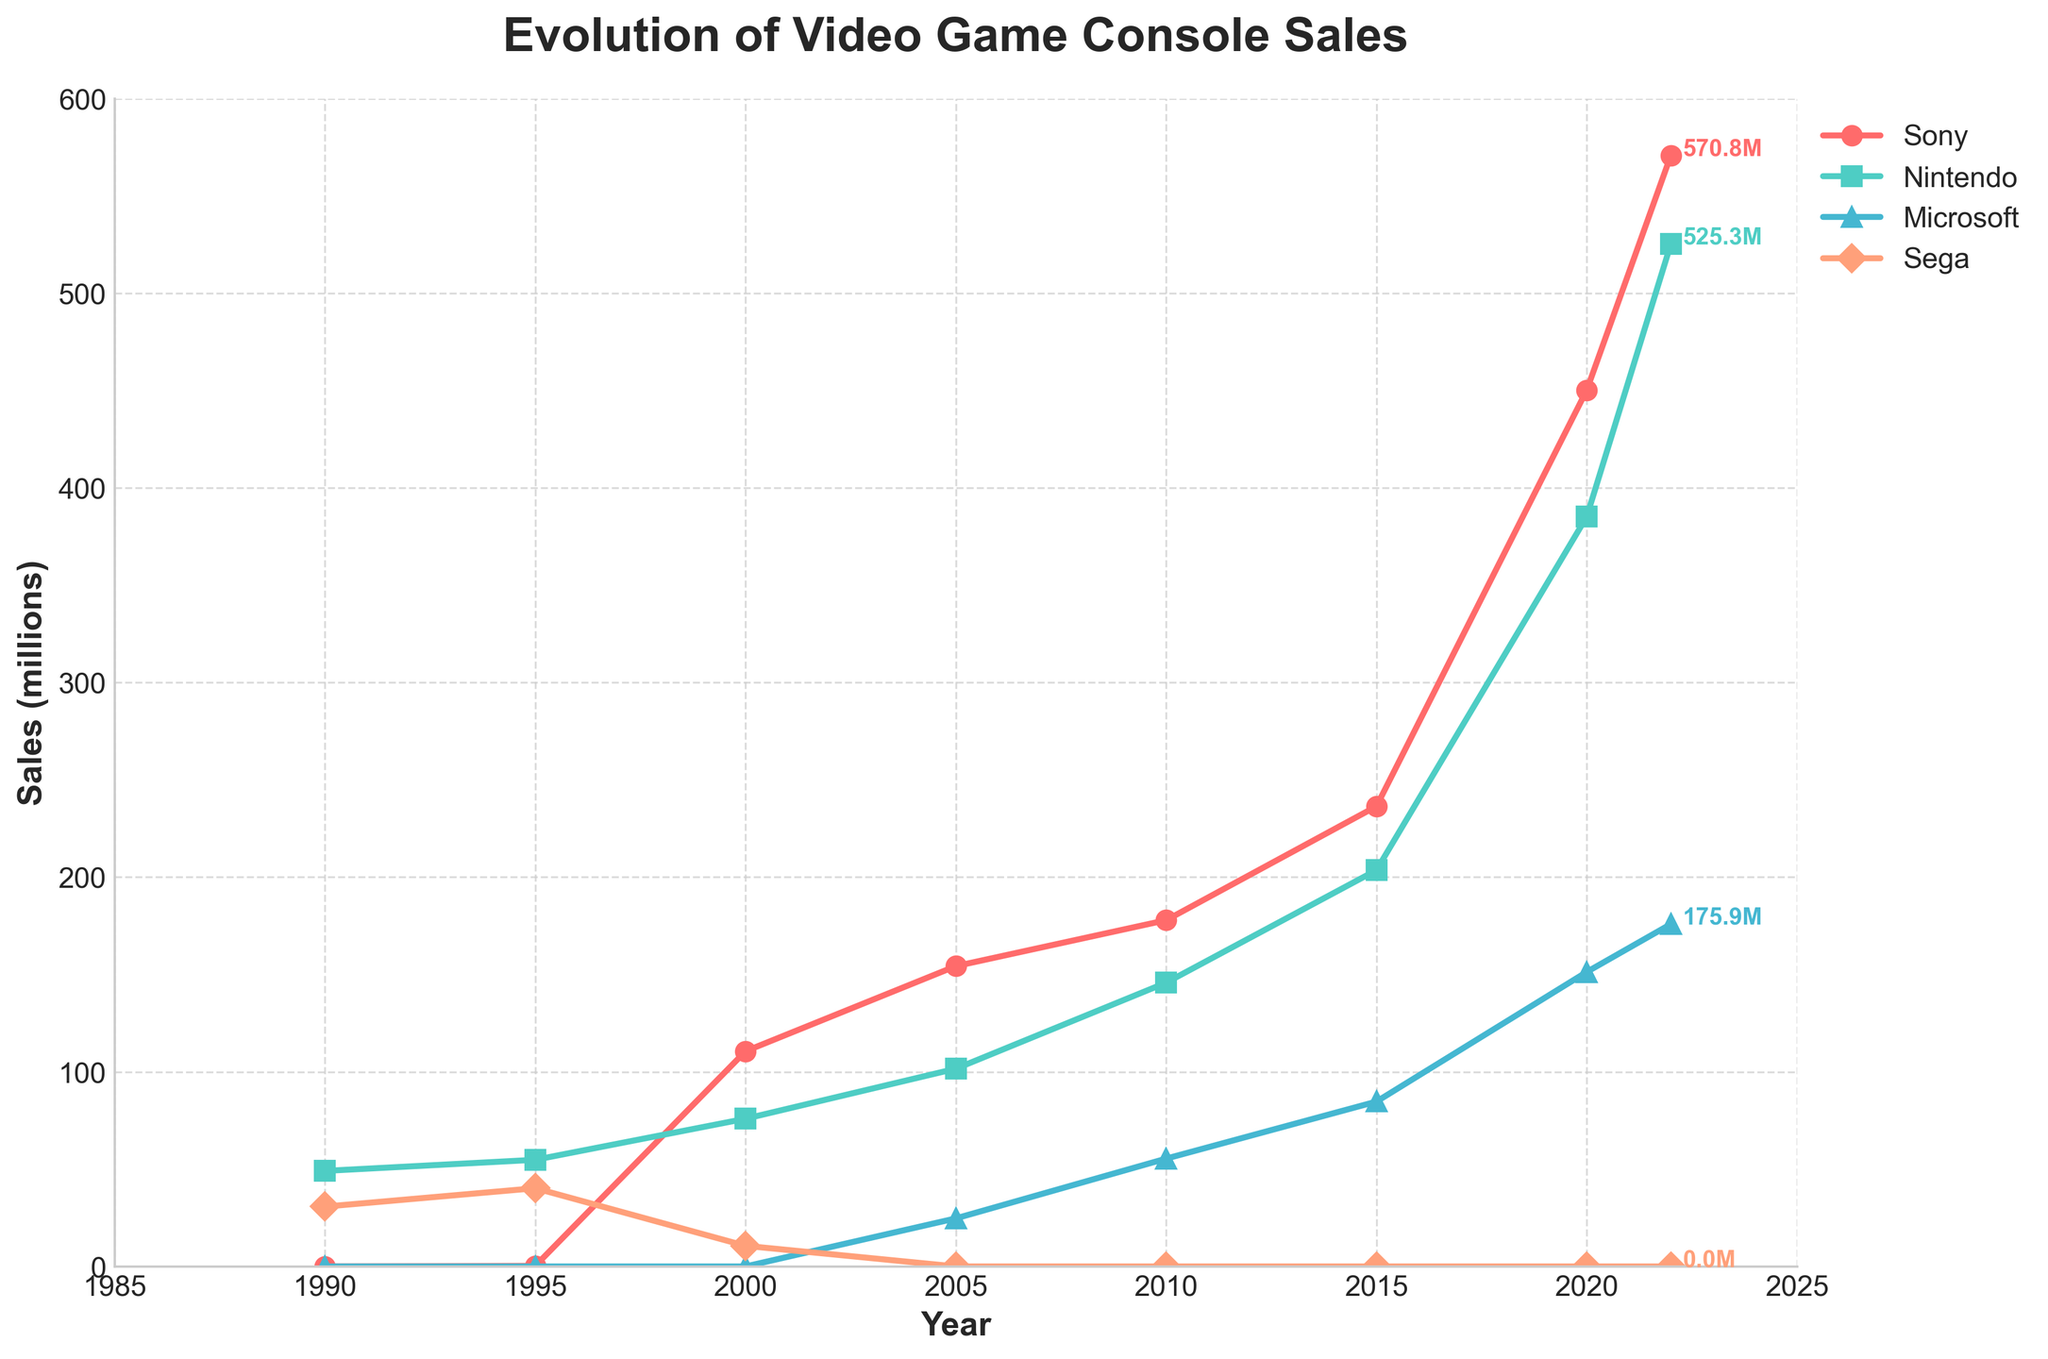Which manufacturer had the highest sales in 2022? From the figure, observe that Sony has the highest point on the curve for the year 2022 compared to Nintendo and Microsoft.
Answer: Sony By how much did Microsoft's sales increase from 2005 to 2022? Look at the sales of Microsoft for 2005 (24.7 million) and 2022 (175.9 million). Calculate the difference (175.9 - 24.7).
Answer: 151.2 million Compare the sales growth of Sony and Nintendo between 2000 and 2020. Who had a bigger increase? Calculate the difference in sales for Sony (450.2 - 110.6) and Nintendo (385.2 - 75.9). Compare the differences: Sony's increase is 339.6 million, and Nintendo's increase is 309.3 million.
Answer: Sony Which company dropped out of the market after 2000? Identify the company whose sales line ends at the year 2000. The line for Sega stops after 2000.
Answer: Sega What were the total sales for Sony, Nintendo, and Microsoft combined in 2022? Sum the sales of Sony (570.8), Nintendo (525.3), and Microsoft (175.9) for 2022 (570.8 + 525.3 + 175.9).
Answer: 1272 million Which year did Sony's sales first surpass 150 million? Identify the year when Sony's sales line crosses the 150 million mark for the first time, which happens in 2005.
Answer: 2005 What is the approximate difference in sales between Sony and Nintendo in 2020? Find the difference between Sony's sales (450.2) and Nintendo's sales (385.2) for 2020. Calculate (450.2 - 385.2).
Answer: 65 million How did Sega's sales trend from 1990 to 2000? Observe the trend line for Sega, which starts at 30.75 million in 1990 and drops to 10.6 million in 2000.
Answer: Decreased Which year showed the biggest sales leap for Nintendo? Identify the steepest rise in Nintendo's sales line by checking the gaps between two successive points. The largest delta is between 2015 (203.6 million) and 2020 (385.2 million).
Answer: 2015 to 2020 